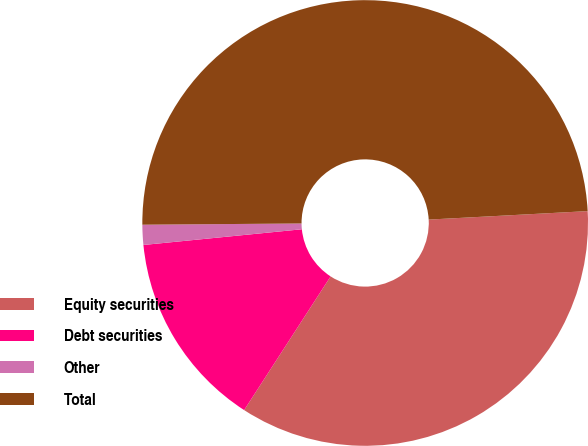Convert chart. <chart><loc_0><loc_0><loc_500><loc_500><pie_chart><fcel>Equity securities<fcel>Debt securities<fcel>Other<fcel>Total<nl><fcel>34.99%<fcel>14.29%<fcel>1.45%<fcel>49.28%<nl></chart> 